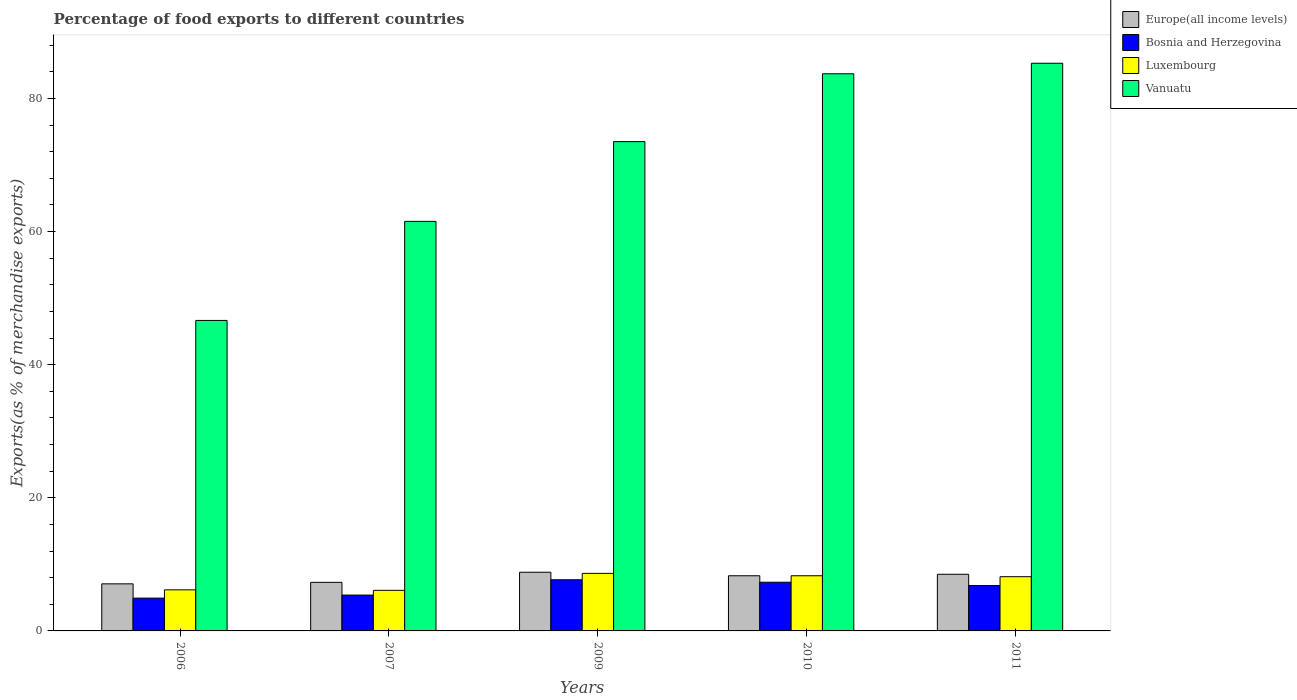How many different coloured bars are there?
Offer a terse response. 4. Are the number of bars per tick equal to the number of legend labels?
Keep it short and to the point. Yes. Are the number of bars on each tick of the X-axis equal?
Make the answer very short. Yes. How many bars are there on the 4th tick from the left?
Offer a terse response. 4. How many bars are there on the 1st tick from the right?
Give a very brief answer. 4. What is the label of the 1st group of bars from the left?
Provide a short and direct response. 2006. What is the percentage of exports to different countries in Vanuatu in 2011?
Offer a terse response. 85.29. Across all years, what is the maximum percentage of exports to different countries in Luxembourg?
Your answer should be very brief. 8.65. Across all years, what is the minimum percentage of exports to different countries in Bosnia and Herzegovina?
Your response must be concise. 4.93. What is the total percentage of exports to different countries in Europe(all income levels) in the graph?
Keep it short and to the point. 39.99. What is the difference between the percentage of exports to different countries in Bosnia and Herzegovina in 2007 and that in 2010?
Ensure brevity in your answer.  -1.93. What is the difference between the percentage of exports to different countries in Europe(all income levels) in 2011 and the percentage of exports to different countries in Luxembourg in 2006?
Make the answer very short. 2.34. What is the average percentage of exports to different countries in Europe(all income levels) per year?
Ensure brevity in your answer.  8. In the year 2006, what is the difference between the percentage of exports to different countries in Vanuatu and percentage of exports to different countries in Europe(all income levels)?
Your answer should be compact. 39.58. In how many years, is the percentage of exports to different countries in Vanuatu greater than 68 %?
Provide a short and direct response. 3. What is the ratio of the percentage of exports to different countries in Luxembourg in 2006 to that in 2007?
Provide a succinct answer. 1.01. What is the difference between the highest and the second highest percentage of exports to different countries in Vanuatu?
Ensure brevity in your answer.  1.58. What is the difference between the highest and the lowest percentage of exports to different countries in Bosnia and Herzegovina?
Provide a short and direct response. 2.76. In how many years, is the percentage of exports to different countries in Europe(all income levels) greater than the average percentage of exports to different countries in Europe(all income levels) taken over all years?
Ensure brevity in your answer.  3. Is the sum of the percentage of exports to different countries in Bosnia and Herzegovina in 2009 and 2010 greater than the maximum percentage of exports to different countries in Luxembourg across all years?
Keep it short and to the point. Yes. Is it the case that in every year, the sum of the percentage of exports to different countries in Luxembourg and percentage of exports to different countries in Bosnia and Herzegovina is greater than the sum of percentage of exports to different countries in Europe(all income levels) and percentage of exports to different countries in Vanuatu?
Keep it short and to the point. No. What does the 2nd bar from the left in 2011 represents?
Offer a terse response. Bosnia and Herzegovina. What does the 1st bar from the right in 2006 represents?
Provide a succinct answer. Vanuatu. How many bars are there?
Make the answer very short. 20. Are all the bars in the graph horizontal?
Your answer should be very brief. No. What is the difference between two consecutive major ticks on the Y-axis?
Offer a terse response. 20. Does the graph contain any zero values?
Make the answer very short. No. Where does the legend appear in the graph?
Keep it short and to the point. Top right. How many legend labels are there?
Ensure brevity in your answer.  4. How are the legend labels stacked?
Your answer should be compact. Vertical. What is the title of the graph?
Offer a very short reply. Percentage of food exports to different countries. What is the label or title of the X-axis?
Your answer should be very brief. Years. What is the label or title of the Y-axis?
Make the answer very short. Exports(as % of merchandise exports). What is the Exports(as % of merchandise exports) in Europe(all income levels) in 2006?
Provide a short and direct response. 7.07. What is the Exports(as % of merchandise exports) of Bosnia and Herzegovina in 2006?
Your response must be concise. 4.93. What is the Exports(as % of merchandise exports) in Luxembourg in 2006?
Offer a very short reply. 6.17. What is the Exports(as % of merchandise exports) of Vanuatu in 2006?
Your answer should be very brief. 46.65. What is the Exports(as % of merchandise exports) of Europe(all income levels) in 2007?
Provide a short and direct response. 7.3. What is the Exports(as % of merchandise exports) of Bosnia and Herzegovina in 2007?
Offer a terse response. 5.39. What is the Exports(as % of merchandise exports) in Luxembourg in 2007?
Keep it short and to the point. 6.1. What is the Exports(as % of merchandise exports) of Vanuatu in 2007?
Make the answer very short. 61.54. What is the Exports(as % of merchandise exports) of Europe(all income levels) in 2009?
Provide a short and direct response. 8.82. What is the Exports(as % of merchandise exports) in Bosnia and Herzegovina in 2009?
Ensure brevity in your answer.  7.69. What is the Exports(as % of merchandise exports) of Luxembourg in 2009?
Your answer should be very brief. 8.65. What is the Exports(as % of merchandise exports) in Vanuatu in 2009?
Make the answer very short. 73.52. What is the Exports(as % of merchandise exports) of Europe(all income levels) in 2010?
Your response must be concise. 8.29. What is the Exports(as % of merchandise exports) of Bosnia and Herzegovina in 2010?
Your answer should be very brief. 7.32. What is the Exports(as % of merchandise exports) of Luxembourg in 2010?
Your response must be concise. 8.29. What is the Exports(as % of merchandise exports) in Vanuatu in 2010?
Ensure brevity in your answer.  83.71. What is the Exports(as % of merchandise exports) in Europe(all income levels) in 2011?
Your answer should be very brief. 8.51. What is the Exports(as % of merchandise exports) of Bosnia and Herzegovina in 2011?
Your answer should be very brief. 6.81. What is the Exports(as % of merchandise exports) of Luxembourg in 2011?
Make the answer very short. 8.15. What is the Exports(as % of merchandise exports) in Vanuatu in 2011?
Provide a short and direct response. 85.29. Across all years, what is the maximum Exports(as % of merchandise exports) of Europe(all income levels)?
Your answer should be very brief. 8.82. Across all years, what is the maximum Exports(as % of merchandise exports) of Bosnia and Herzegovina?
Ensure brevity in your answer.  7.69. Across all years, what is the maximum Exports(as % of merchandise exports) of Luxembourg?
Give a very brief answer. 8.65. Across all years, what is the maximum Exports(as % of merchandise exports) in Vanuatu?
Keep it short and to the point. 85.29. Across all years, what is the minimum Exports(as % of merchandise exports) in Europe(all income levels)?
Offer a terse response. 7.07. Across all years, what is the minimum Exports(as % of merchandise exports) of Bosnia and Herzegovina?
Keep it short and to the point. 4.93. Across all years, what is the minimum Exports(as % of merchandise exports) of Luxembourg?
Offer a very short reply. 6.1. Across all years, what is the minimum Exports(as % of merchandise exports) of Vanuatu?
Offer a very short reply. 46.65. What is the total Exports(as % of merchandise exports) of Europe(all income levels) in the graph?
Ensure brevity in your answer.  39.99. What is the total Exports(as % of merchandise exports) of Bosnia and Herzegovina in the graph?
Offer a very short reply. 32.13. What is the total Exports(as % of merchandise exports) in Luxembourg in the graph?
Keep it short and to the point. 37.35. What is the total Exports(as % of merchandise exports) in Vanuatu in the graph?
Provide a succinct answer. 350.71. What is the difference between the Exports(as % of merchandise exports) in Europe(all income levels) in 2006 and that in 2007?
Make the answer very short. -0.23. What is the difference between the Exports(as % of merchandise exports) of Bosnia and Herzegovina in 2006 and that in 2007?
Offer a very short reply. -0.46. What is the difference between the Exports(as % of merchandise exports) of Luxembourg in 2006 and that in 2007?
Give a very brief answer. 0.07. What is the difference between the Exports(as % of merchandise exports) of Vanuatu in 2006 and that in 2007?
Your response must be concise. -14.88. What is the difference between the Exports(as % of merchandise exports) in Europe(all income levels) in 2006 and that in 2009?
Your response must be concise. -1.74. What is the difference between the Exports(as % of merchandise exports) of Bosnia and Herzegovina in 2006 and that in 2009?
Your answer should be very brief. -2.76. What is the difference between the Exports(as % of merchandise exports) in Luxembourg in 2006 and that in 2009?
Your answer should be compact. -2.47. What is the difference between the Exports(as % of merchandise exports) in Vanuatu in 2006 and that in 2009?
Provide a short and direct response. -26.87. What is the difference between the Exports(as % of merchandise exports) in Europe(all income levels) in 2006 and that in 2010?
Provide a short and direct response. -1.21. What is the difference between the Exports(as % of merchandise exports) of Bosnia and Herzegovina in 2006 and that in 2010?
Keep it short and to the point. -2.39. What is the difference between the Exports(as % of merchandise exports) in Luxembourg in 2006 and that in 2010?
Offer a terse response. -2.12. What is the difference between the Exports(as % of merchandise exports) in Vanuatu in 2006 and that in 2010?
Offer a very short reply. -37.06. What is the difference between the Exports(as % of merchandise exports) of Europe(all income levels) in 2006 and that in 2011?
Offer a very short reply. -1.44. What is the difference between the Exports(as % of merchandise exports) of Bosnia and Herzegovina in 2006 and that in 2011?
Your answer should be very brief. -1.88. What is the difference between the Exports(as % of merchandise exports) in Luxembourg in 2006 and that in 2011?
Give a very brief answer. -1.98. What is the difference between the Exports(as % of merchandise exports) in Vanuatu in 2006 and that in 2011?
Keep it short and to the point. -38.64. What is the difference between the Exports(as % of merchandise exports) in Europe(all income levels) in 2007 and that in 2009?
Your answer should be compact. -1.52. What is the difference between the Exports(as % of merchandise exports) in Luxembourg in 2007 and that in 2009?
Keep it short and to the point. -2.55. What is the difference between the Exports(as % of merchandise exports) in Vanuatu in 2007 and that in 2009?
Your answer should be very brief. -11.98. What is the difference between the Exports(as % of merchandise exports) of Europe(all income levels) in 2007 and that in 2010?
Ensure brevity in your answer.  -0.99. What is the difference between the Exports(as % of merchandise exports) in Bosnia and Herzegovina in 2007 and that in 2010?
Offer a terse response. -1.93. What is the difference between the Exports(as % of merchandise exports) of Luxembourg in 2007 and that in 2010?
Keep it short and to the point. -2.19. What is the difference between the Exports(as % of merchandise exports) of Vanuatu in 2007 and that in 2010?
Offer a very short reply. -22.18. What is the difference between the Exports(as % of merchandise exports) of Europe(all income levels) in 2007 and that in 2011?
Your response must be concise. -1.21. What is the difference between the Exports(as % of merchandise exports) of Bosnia and Herzegovina in 2007 and that in 2011?
Make the answer very short. -1.43. What is the difference between the Exports(as % of merchandise exports) in Luxembourg in 2007 and that in 2011?
Your answer should be very brief. -2.05. What is the difference between the Exports(as % of merchandise exports) in Vanuatu in 2007 and that in 2011?
Provide a succinct answer. -23.75. What is the difference between the Exports(as % of merchandise exports) of Europe(all income levels) in 2009 and that in 2010?
Your answer should be compact. 0.53. What is the difference between the Exports(as % of merchandise exports) in Bosnia and Herzegovina in 2009 and that in 2010?
Your answer should be compact. 0.37. What is the difference between the Exports(as % of merchandise exports) in Luxembourg in 2009 and that in 2010?
Make the answer very short. 0.36. What is the difference between the Exports(as % of merchandise exports) of Vanuatu in 2009 and that in 2010?
Provide a succinct answer. -10.19. What is the difference between the Exports(as % of merchandise exports) of Europe(all income levels) in 2009 and that in 2011?
Ensure brevity in your answer.  0.31. What is the difference between the Exports(as % of merchandise exports) in Bosnia and Herzegovina in 2009 and that in 2011?
Your response must be concise. 0.87. What is the difference between the Exports(as % of merchandise exports) in Luxembourg in 2009 and that in 2011?
Provide a succinct answer. 0.5. What is the difference between the Exports(as % of merchandise exports) of Vanuatu in 2009 and that in 2011?
Your answer should be compact. -11.77. What is the difference between the Exports(as % of merchandise exports) of Europe(all income levels) in 2010 and that in 2011?
Give a very brief answer. -0.22. What is the difference between the Exports(as % of merchandise exports) of Bosnia and Herzegovina in 2010 and that in 2011?
Ensure brevity in your answer.  0.5. What is the difference between the Exports(as % of merchandise exports) of Luxembourg in 2010 and that in 2011?
Your answer should be very brief. 0.14. What is the difference between the Exports(as % of merchandise exports) in Vanuatu in 2010 and that in 2011?
Offer a very short reply. -1.58. What is the difference between the Exports(as % of merchandise exports) of Europe(all income levels) in 2006 and the Exports(as % of merchandise exports) of Bosnia and Herzegovina in 2007?
Your answer should be very brief. 1.69. What is the difference between the Exports(as % of merchandise exports) in Europe(all income levels) in 2006 and the Exports(as % of merchandise exports) in Luxembourg in 2007?
Keep it short and to the point. 0.98. What is the difference between the Exports(as % of merchandise exports) of Europe(all income levels) in 2006 and the Exports(as % of merchandise exports) of Vanuatu in 2007?
Make the answer very short. -54.46. What is the difference between the Exports(as % of merchandise exports) of Bosnia and Herzegovina in 2006 and the Exports(as % of merchandise exports) of Luxembourg in 2007?
Your answer should be very brief. -1.17. What is the difference between the Exports(as % of merchandise exports) of Bosnia and Herzegovina in 2006 and the Exports(as % of merchandise exports) of Vanuatu in 2007?
Your answer should be very brief. -56.61. What is the difference between the Exports(as % of merchandise exports) in Luxembourg in 2006 and the Exports(as % of merchandise exports) in Vanuatu in 2007?
Offer a terse response. -55.36. What is the difference between the Exports(as % of merchandise exports) of Europe(all income levels) in 2006 and the Exports(as % of merchandise exports) of Bosnia and Herzegovina in 2009?
Ensure brevity in your answer.  -0.61. What is the difference between the Exports(as % of merchandise exports) in Europe(all income levels) in 2006 and the Exports(as % of merchandise exports) in Luxembourg in 2009?
Your answer should be compact. -1.57. What is the difference between the Exports(as % of merchandise exports) in Europe(all income levels) in 2006 and the Exports(as % of merchandise exports) in Vanuatu in 2009?
Your answer should be compact. -66.44. What is the difference between the Exports(as % of merchandise exports) in Bosnia and Herzegovina in 2006 and the Exports(as % of merchandise exports) in Luxembourg in 2009?
Provide a succinct answer. -3.72. What is the difference between the Exports(as % of merchandise exports) of Bosnia and Herzegovina in 2006 and the Exports(as % of merchandise exports) of Vanuatu in 2009?
Provide a succinct answer. -68.59. What is the difference between the Exports(as % of merchandise exports) of Luxembourg in 2006 and the Exports(as % of merchandise exports) of Vanuatu in 2009?
Your response must be concise. -67.35. What is the difference between the Exports(as % of merchandise exports) in Europe(all income levels) in 2006 and the Exports(as % of merchandise exports) in Bosnia and Herzegovina in 2010?
Provide a succinct answer. -0.24. What is the difference between the Exports(as % of merchandise exports) of Europe(all income levels) in 2006 and the Exports(as % of merchandise exports) of Luxembourg in 2010?
Provide a short and direct response. -1.22. What is the difference between the Exports(as % of merchandise exports) of Europe(all income levels) in 2006 and the Exports(as % of merchandise exports) of Vanuatu in 2010?
Ensure brevity in your answer.  -76.64. What is the difference between the Exports(as % of merchandise exports) of Bosnia and Herzegovina in 2006 and the Exports(as % of merchandise exports) of Luxembourg in 2010?
Your response must be concise. -3.36. What is the difference between the Exports(as % of merchandise exports) in Bosnia and Herzegovina in 2006 and the Exports(as % of merchandise exports) in Vanuatu in 2010?
Offer a terse response. -78.78. What is the difference between the Exports(as % of merchandise exports) in Luxembourg in 2006 and the Exports(as % of merchandise exports) in Vanuatu in 2010?
Make the answer very short. -77.54. What is the difference between the Exports(as % of merchandise exports) of Europe(all income levels) in 2006 and the Exports(as % of merchandise exports) of Bosnia and Herzegovina in 2011?
Make the answer very short. 0.26. What is the difference between the Exports(as % of merchandise exports) in Europe(all income levels) in 2006 and the Exports(as % of merchandise exports) in Luxembourg in 2011?
Offer a very short reply. -1.07. What is the difference between the Exports(as % of merchandise exports) of Europe(all income levels) in 2006 and the Exports(as % of merchandise exports) of Vanuatu in 2011?
Your response must be concise. -78.22. What is the difference between the Exports(as % of merchandise exports) in Bosnia and Herzegovina in 2006 and the Exports(as % of merchandise exports) in Luxembourg in 2011?
Your answer should be very brief. -3.22. What is the difference between the Exports(as % of merchandise exports) of Bosnia and Herzegovina in 2006 and the Exports(as % of merchandise exports) of Vanuatu in 2011?
Your answer should be very brief. -80.36. What is the difference between the Exports(as % of merchandise exports) of Luxembourg in 2006 and the Exports(as % of merchandise exports) of Vanuatu in 2011?
Provide a short and direct response. -79.12. What is the difference between the Exports(as % of merchandise exports) in Europe(all income levels) in 2007 and the Exports(as % of merchandise exports) in Bosnia and Herzegovina in 2009?
Your answer should be compact. -0.39. What is the difference between the Exports(as % of merchandise exports) in Europe(all income levels) in 2007 and the Exports(as % of merchandise exports) in Luxembourg in 2009?
Keep it short and to the point. -1.35. What is the difference between the Exports(as % of merchandise exports) in Europe(all income levels) in 2007 and the Exports(as % of merchandise exports) in Vanuatu in 2009?
Ensure brevity in your answer.  -66.22. What is the difference between the Exports(as % of merchandise exports) in Bosnia and Herzegovina in 2007 and the Exports(as % of merchandise exports) in Luxembourg in 2009?
Keep it short and to the point. -3.26. What is the difference between the Exports(as % of merchandise exports) in Bosnia and Herzegovina in 2007 and the Exports(as % of merchandise exports) in Vanuatu in 2009?
Offer a very short reply. -68.13. What is the difference between the Exports(as % of merchandise exports) in Luxembourg in 2007 and the Exports(as % of merchandise exports) in Vanuatu in 2009?
Your response must be concise. -67.42. What is the difference between the Exports(as % of merchandise exports) in Europe(all income levels) in 2007 and the Exports(as % of merchandise exports) in Bosnia and Herzegovina in 2010?
Your response must be concise. -0.02. What is the difference between the Exports(as % of merchandise exports) of Europe(all income levels) in 2007 and the Exports(as % of merchandise exports) of Luxembourg in 2010?
Your answer should be very brief. -0.99. What is the difference between the Exports(as % of merchandise exports) of Europe(all income levels) in 2007 and the Exports(as % of merchandise exports) of Vanuatu in 2010?
Make the answer very short. -76.41. What is the difference between the Exports(as % of merchandise exports) of Bosnia and Herzegovina in 2007 and the Exports(as % of merchandise exports) of Luxembourg in 2010?
Your answer should be very brief. -2.9. What is the difference between the Exports(as % of merchandise exports) in Bosnia and Herzegovina in 2007 and the Exports(as % of merchandise exports) in Vanuatu in 2010?
Keep it short and to the point. -78.32. What is the difference between the Exports(as % of merchandise exports) in Luxembourg in 2007 and the Exports(as % of merchandise exports) in Vanuatu in 2010?
Provide a short and direct response. -77.61. What is the difference between the Exports(as % of merchandise exports) of Europe(all income levels) in 2007 and the Exports(as % of merchandise exports) of Bosnia and Herzegovina in 2011?
Your answer should be very brief. 0.49. What is the difference between the Exports(as % of merchandise exports) of Europe(all income levels) in 2007 and the Exports(as % of merchandise exports) of Luxembourg in 2011?
Provide a succinct answer. -0.85. What is the difference between the Exports(as % of merchandise exports) of Europe(all income levels) in 2007 and the Exports(as % of merchandise exports) of Vanuatu in 2011?
Provide a short and direct response. -77.99. What is the difference between the Exports(as % of merchandise exports) of Bosnia and Herzegovina in 2007 and the Exports(as % of merchandise exports) of Luxembourg in 2011?
Make the answer very short. -2.76. What is the difference between the Exports(as % of merchandise exports) in Bosnia and Herzegovina in 2007 and the Exports(as % of merchandise exports) in Vanuatu in 2011?
Your response must be concise. -79.9. What is the difference between the Exports(as % of merchandise exports) of Luxembourg in 2007 and the Exports(as % of merchandise exports) of Vanuatu in 2011?
Provide a short and direct response. -79.19. What is the difference between the Exports(as % of merchandise exports) in Europe(all income levels) in 2009 and the Exports(as % of merchandise exports) in Bosnia and Herzegovina in 2010?
Your answer should be very brief. 1.5. What is the difference between the Exports(as % of merchandise exports) in Europe(all income levels) in 2009 and the Exports(as % of merchandise exports) in Luxembourg in 2010?
Give a very brief answer. 0.53. What is the difference between the Exports(as % of merchandise exports) in Europe(all income levels) in 2009 and the Exports(as % of merchandise exports) in Vanuatu in 2010?
Offer a very short reply. -74.89. What is the difference between the Exports(as % of merchandise exports) in Bosnia and Herzegovina in 2009 and the Exports(as % of merchandise exports) in Luxembourg in 2010?
Your answer should be very brief. -0.6. What is the difference between the Exports(as % of merchandise exports) of Bosnia and Herzegovina in 2009 and the Exports(as % of merchandise exports) of Vanuatu in 2010?
Provide a short and direct response. -76.02. What is the difference between the Exports(as % of merchandise exports) of Luxembourg in 2009 and the Exports(as % of merchandise exports) of Vanuatu in 2010?
Your answer should be compact. -75.06. What is the difference between the Exports(as % of merchandise exports) of Europe(all income levels) in 2009 and the Exports(as % of merchandise exports) of Bosnia and Herzegovina in 2011?
Ensure brevity in your answer.  2. What is the difference between the Exports(as % of merchandise exports) of Europe(all income levels) in 2009 and the Exports(as % of merchandise exports) of Luxembourg in 2011?
Provide a short and direct response. 0.67. What is the difference between the Exports(as % of merchandise exports) in Europe(all income levels) in 2009 and the Exports(as % of merchandise exports) in Vanuatu in 2011?
Provide a short and direct response. -76.47. What is the difference between the Exports(as % of merchandise exports) of Bosnia and Herzegovina in 2009 and the Exports(as % of merchandise exports) of Luxembourg in 2011?
Your answer should be compact. -0.46. What is the difference between the Exports(as % of merchandise exports) in Bosnia and Herzegovina in 2009 and the Exports(as % of merchandise exports) in Vanuatu in 2011?
Offer a terse response. -77.6. What is the difference between the Exports(as % of merchandise exports) in Luxembourg in 2009 and the Exports(as % of merchandise exports) in Vanuatu in 2011?
Your response must be concise. -76.64. What is the difference between the Exports(as % of merchandise exports) of Europe(all income levels) in 2010 and the Exports(as % of merchandise exports) of Bosnia and Herzegovina in 2011?
Offer a very short reply. 1.47. What is the difference between the Exports(as % of merchandise exports) of Europe(all income levels) in 2010 and the Exports(as % of merchandise exports) of Luxembourg in 2011?
Give a very brief answer. 0.14. What is the difference between the Exports(as % of merchandise exports) in Europe(all income levels) in 2010 and the Exports(as % of merchandise exports) in Vanuatu in 2011?
Offer a very short reply. -77. What is the difference between the Exports(as % of merchandise exports) of Bosnia and Herzegovina in 2010 and the Exports(as % of merchandise exports) of Luxembourg in 2011?
Offer a very short reply. -0.83. What is the difference between the Exports(as % of merchandise exports) in Bosnia and Herzegovina in 2010 and the Exports(as % of merchandise exports) in Vanuatu in 2011?
Give a very brief answer. -77.97. What is the difference between the Exports(as % of merchandise exports) in Luxembourg in 2010 and the Exports(as % of merchandise exports) in Vanuatu in 2011?
Ensure brevity in your answer.  -77. What is the average Exports(as % of merchandise exports) of Europe(all income levels) per year?
Give a very brief answer. 8. What is the average Exports(as % of merchandise exports) of Bosnia and Herzegovina per year?
Your answer should be compact. 6.43. What is the average Exports(as % of merchandise exports) in Luxembourg per year?
Ensure brevity in your answer.  7.47. What is the average Exports(as % of merchandise exports) of Vanuatu per year?
Your response must be concise. 70.14. In the year 2006, what is the difference between the Exports(as % of merchandise exports) of Europe(all income levels) and Exports(as % of merchandise exports) of Bosnia and Herzegovina?
Make the answer very short. 2.15. In the year 2006, what is the difference between the Exports(as % of merchandise exports) in Europe(all income levels) and Exports(as % of merchandise exports) in Luxembourg?
Ensure brevity in your answer.  0.9. In the year 2006, what is the difference between the Exports(as % of merchandise exports) of Europe(all income levels) and Exports(as % of merchandise exports) of Vanuatu?
Make the answer very short. -39.58. In the year 2006, what is the difference between the Exports(as % of merchandise exports) of Bosnia and Herzegovina and Exports(as % of merchandise exports) of Luxembourg?
Provide a short and direct response. -1.24. In the year 2006, what is the difference between the Exports(as % of merchandise exports) in Bosnia and Herzegovina and Exports(as % of merchandise exports) in Vanuatu?
Your answer should be very brief. -41.72. In the year 2006, what is the difference between the Exports(as % of merchandise exports) of Luxembourg and Exports(as % of merchandise exports) of Vanuatu?
Offer a terse response. -40.48. In the year 2007, what is the difference between the Exports(as % of merchandise exports) in Europe(all income levels) and Exports(as % of merchandise exports) in Bosnia and Herzegovina?
Offer a terse response. 1.91. In the year 2007, what is the difference between the Exports(as % of merchandise exports) of Europe(all income levels) and Exports(as % of merchandise exports) of Luxembourg?
Your response must be concise. 1.2. In the year 2007, what is the difference between the Exports(as % of merchandise exports) of Europe(all income levels) and Exports(as % of merchandise exports) of Vanuatu?
Your answer should be very brief. -54.24. In the year 2007, what is the difference between the Exports(as % of merchandise exports) in Bosnia and Herzegovina and Exports(as % of merchandise exports) in Luxembourg?
Ensure brevity in your answer.  -0.71. In the year 2007, what is the difference between the Exports(as % of merchandise exports) of Bosnia and Herzegovina and Exports(as % of merchandise exports) of Vanuatu?
Your response must be concise. -56.15. In the year 2007, what is the difference between the Exports(as % of merchandise exports) in Luxembourg and Exports(as % of merchandise exports) in Vanuatu?
Your response must be concise. -55.44. In the year 2009, what is the difference between the Exports(as % of merchandise exports) in Europe(all income levels) and Exports(as % of merchandise exports) in Bosnia and Herzegovina?
Ensure brevity in your answer.  1.13. In the year 2009, what is the difference between the Exports(as % of merchandise exports) of Europe(all income levels) and Exports(as % of merchandise exports) of Luxembourg?
Your answer should be very brief. 0.17. In the year 2009, what is the difference between the Exports(as % of merchandise exports) in Europe(all income levels) and Exports(as % of merchandise exports) in Vanuatu?
Give a very brief answer. -64.7. In the year 2009, what is the difference between the Exports(as % of merchandise exports) in Bosnia and Herzegovina and Exports(as % of merchandise exports) in Luxembourg?
Provide a succinct answer. -0.96. In the year 2009, what is the difference between the Exports(as % of merchandise exports) in Bosnia and Herzegovina and Exports(as % of merchandise exports) in Vanuatu?
Make the answer very short. -65.83. In the year 2009, what is the difference between the Exports(as % of merchandise exports) of Luxembourg and Exports(as % of merchandise exports) of Vanuatu?
Provide a short and direct response. -64.87. In the year 2010, what is the difference between the Exports(as % of merchandise exports) in Europe(all income levels) and Exports(as % of merchandise exports) in Bosnia and Herzegovina?
Offer a very short reply. 0.97. In the year 2010, what is the difference between the Exports(as % of merchandise exports) of Europe(all income levels) and Exports(as % of merchandise exports) of Luxembourg?
Offer a very short reply. -0. In the year 2010, what is the difference between the Exports(as % of merchandise exports) of Europe(all income levels) and Exports(as % of merchandise exports) of Vanuatu?
Your response must be concise. -75.42. In the year 2010, what is the difference between the Exports(as % of merchandise exports) in Bosnia and Herzegovina and Exports(as % of merchandise exports) in Luxembourg?
Offer a terse response. -0.97. In the year 2010, what is the difference between the Exports(as % of merchandise exports) in Bosnia and Herzegovina and Exports(as % of merchandise exports) in Vanuatu?
Your answer should be very brief. -76.39. In the year 2010, what is the difference between the Exports(as % of merchandise exports) in Luxembourg and Exports(as % of merchandise exports) in Vanuatu?
Offer a terse response. -75.42. In the year 2011, what is the difference between the Exports(as % of merchandise exports) in Europe(all income levels) and Exports(as % of merchandise exports) in Bosnia and Herzegovina?
Provide a succinct answer. 1.7. In the year 2011, what is the difference between the Exports(as % of merchandise exports) of Europe(all income levels) and Exports(as % of merchandise exports) of Luxembourg?
Provide a succinct answer. 0.36. In the year 2011, what is the difference between the Exports(as % of merchandise exports) in Europe(all income levels) and Exports(as % of merchandise exports) in Vanuatu?
Offer a very short reply. -76.78. In the year 2011, what is the difference between the Exports(as % of merchandise exports) in Bosnia and Herzegovina and Exports(as % of merchandise exports) in Luxembourg?
Give a very brief answer. -1.33. In the year 2011, what is the difference between the Exports(as % of merchandise exports) in Bosnia and Herzegovina and Exports(as % of merchandise exports) in Vanuatu?
Your answer should be very brief. -78.48. In the year 2011, what is the difference between the Exports(as % of merchandise exports) of Luxembourg and Exports(as % of merchandise exports) of Vanuatu?
Your answer should be compact. -77.14. What is the ratio of the Exports(as % of merchandise exports) in Europe(all income levels) in 2006 to that in 2007?
Your answer should be compact. 0.97. What is the ratio of the Exports(as % of merchandise exports) in Bosnia and Herzegovina in 2006 to that in 2007?
Keep it short and to the point. 0.92. What is the ratio of the Exports(as % of merchandise exports) of Luxembourg in 2006 to that in 2007?
Give a very brief answer. 1.01. What is the ratio of the Exports(as % of merchandise exports) of Vanuatu in 2006 to that in 2007?
Your answer should be compact. 0.76. What is the ratio of the Exports(as % of merchandise exports) in Europe(all income levels) in 2006 to that in 2009?
Your answer should be compact. 0.8. What is the ratio of the Exports(as % of merchandise exports) of Bosnia and Herzegovina in 2006 to that in 2009?
Offer a terse response. 0.64. What is the ratio of the Exports(as % of merchandise exports) in Luxembourg in 2006 to that in 2009?
Provide a short and direct response. 0.71. What is the ratio of the Exports(as % of merchandise exports) in Vanuatu in 2006 to that in 2009?
Offer a terse response. 0.63. What is the ratio of the Exports(as % of merchandise exports) in Europe(all income levels) in 2006 to that in 2010?
Your response must be concise. 0.85. What is the ratio of the Exports(as % of merchandise exports) in Bosnia and Herzegovina in 2006 to that in 2010?
Give a very brief answer. 0.67. What is the ratio of the Exports(as % of merchandise exports) in Luxembourg in 2006 to that in 2010?
Your answer should be very brief. 0.74. What is the ratio of the Exports(as % of merchandise exports) in Vanuatu in 2006 to that in 2010?
Offer a terse response. 0.56. What is the ratio of the Exports(as % of merchandise exports) of Europe(all income levels) in 2006 to that in 2011?
Provide a succinct answer. 0.83. What is the ratio of the Exports(as % of merchandise exports) of Bosnia and Herzegovina in 2006 to that in 2011?
Offer a very short reply. 0.72. What is the ratio of the Exports(as % of merchandise exports) in Luxembourg in 2006 to that in 2011?
Your answer should be compact. 0.76. What is the ratio of the Exports(as % of merchandise exports) in Vanuatu in 2006 to that in 2011?
Your response must be concise. 0.55. What is the ratio of the Exports(as % of merchandise exports) of Europe(all income levels) in 2007 to that in 2009?
Give a very brief answer. 0.83. What is the ratio of the Exports(as % of merchandise exports) of Bosnia and Herzegovina in 2007 to that in 2009?
Offer a terse response. 0.7. What is the ratio of the Exports(as % of merchandise exports) of Luxembourg in 2007 to that in 2009?
Ensure brevity in your answer.  0.71. What is the ratio of the Exports(as % of merchandise exports) of Vanuatu in 2007 to that in 2009?
Ensure brevity in your answer.  0.84. What is the ratio of the Exports(as % of merchandise exports) in Europe(all income levels) in 2007 to that in 2010?
Your answer should be compact. 0.88. What is the ratio of the Exports(as % of merchandise exports) of Bosnia and Herzegovina in 2007 to that in 2010?
Give a very brief answer. 0.74. What is the ratio of the Exports(as % of merchandise exports) in Luxembourg in 2007 to that in 2010?
Offer a terse response. 0.74. What is the ratio of the Exports(as % of merchandise exports) of Vanuatu in 2007 to that in 2010?
Ensure brevity in your answer.  0.74. What is the ratio of the Exports(as % of merchandise exports) in Europe(all income levels) in 2007 to that in 2011?
Your response must be concise. 0.86. What is the ratio of the Exports(as % of merchandise exports) of Bosnia and Herzegovina in 2007 to that in 2011?
Ensure brevity in your answer.  0.79. What is the ratio of the Exports(as % of merchandise exports) in Luxembourg in 2007 to that in 2011?
Offer a terse response. 0.75. What is the ratio of the Exports(as % of merchandise exports) of Vanuatu in 2007 to that in 2011?
Keep it short and to the point. 0.72. What is the ratio of the Exports(as % of merchandise exports) of Europe(all income levels) in 2009 to that in 2010?
Your answer should be very brief. 1.06. What is the ratio of the Exports(as % of merchandise exports) of Bosnia and Herzegovina in 2009 to that in 2010?
Your answer should be compact. 1.05. What is the ratio of the Exports(as % of merchandise exports) in Luxembourg in 2009 to that in 2010?
Ensure brevity in your answer.  1.04. What is the ratio of the Exports(as % of merchandise exports) of Vanuatu in 2009 to that in 2010?
Your answer should be very brief. 0.88. What is the ratio of the Exports(as % of merchandise exports) in Europe(all income levels) in 2009 to that in 2011?
Make the answer very short. 1.04. What is the ratio of the Exports(as % of merchandise exports) in Bosnia and Herzegovina in 2009 to that in 2011?
Ensure brevity in your answer.  1.13. What is the ratio of the Exports(as % of merchandise exports) of Luxembourg in 2009 to that in 2011?
Make the answer very short. 1.06. What is the ratio of the Exports(as % of merchandise exports) of Vanuatu in 2009 to that in 2011?
Give a very brief answer. 0.86. What is the ratio of the Exports(as % of merchandise exports) in Europe(all income levels) in 2010 to that in 2011?
Keep it short and to the point. 0.97. What is the ratio of the Exports(as % of merchandise exports) in Bosnia and Herzegovina in 2010 to that in 2011?
Give a very brief answer. 1.07. What is the ratio of the Exports(as % of merchandise exports) in Luxembourg in 2010 to that in 2011?
Offer a very short reply. 1.02. What is the ratio of the Exports(as % of merchandise exports) of Vanuatu in 2010 to that in 2011?
Offer a very short reply. 0.98. What is the difference between the highest and the second highest Exports(as % of merchandise exports) of Europe(all income levels)?
Your answer should be compact. 0.31. What is the difference between the highest and the second highest Exports(as % of merchandise exports) of Bosnia and Herzegovina?
Your answer should be very brief. 0.37. What is the difference between the highest and the second highest Exports(as % of merchandise exports) in Luxembourg?
Your answer should be compact. 0.36. What is the difference between the highest and the second highest Exports(as % of merchandise exports) in Vanuatu?
Give a very brief answer. 1.58. What is the difference between the highest and the lowest Exports(as % of merchandise exports) of Europe(all income levels)?
Your answer should be very brief. 1.74. What is the difference between the highest and the lowest Exports(as % of merchandise exports) of Bosnia and Herzegovina?
Provide a succinct answer. 2.76. What is the difference between the highest and the lowest Exports(as % of merchandise exports) of Luxembourg?
Your answer should be compact. 2.55. What is the difference between the highest and the lowest Exports(as % of merchandise exports) in Vanuatu?
Give a very brief answer. 38.64. 